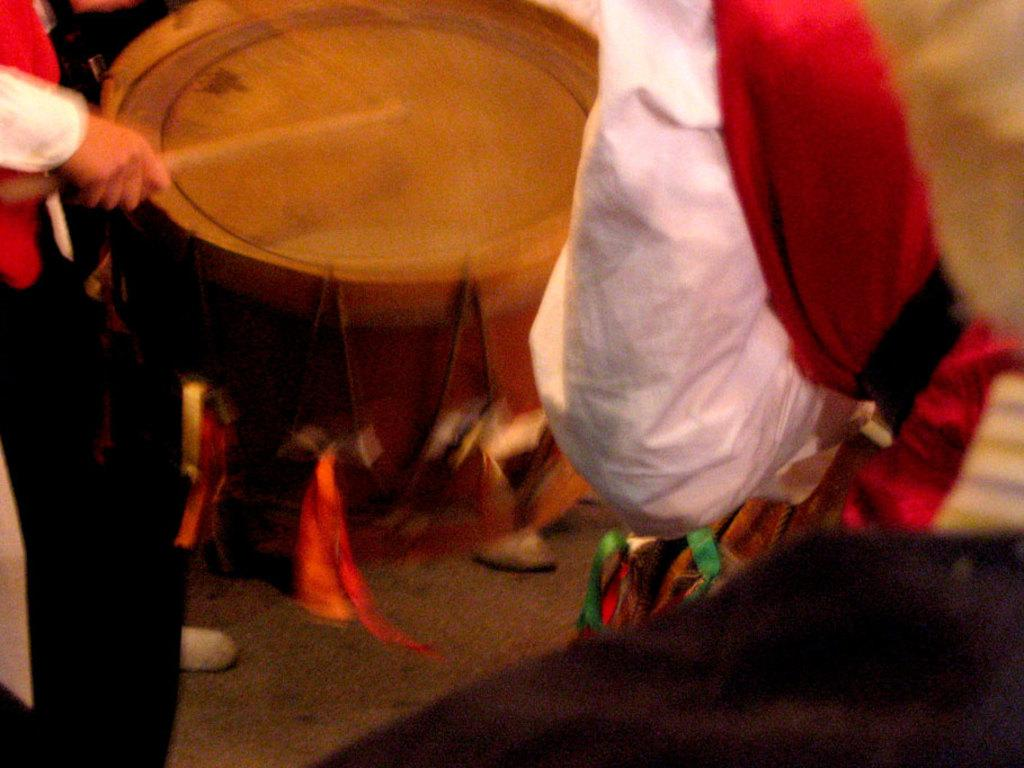What is the main activity being performed in the image? There is a person playing a drum in the image. What is the person holding in his hand? The person is holding a stick in his hand. Can you describe the other person in the image? There is another person standing on the right side of the image. How would you describe the background of the image? The background of the image is blurred. How many boats are docked at the harbor in the image? There is no harbor or boats present in the image; it features a person playing a drum and another person standing nearby. What type of hair is visible on the person playing the drum? There is no visible hair on the person playing the drum in the image. 